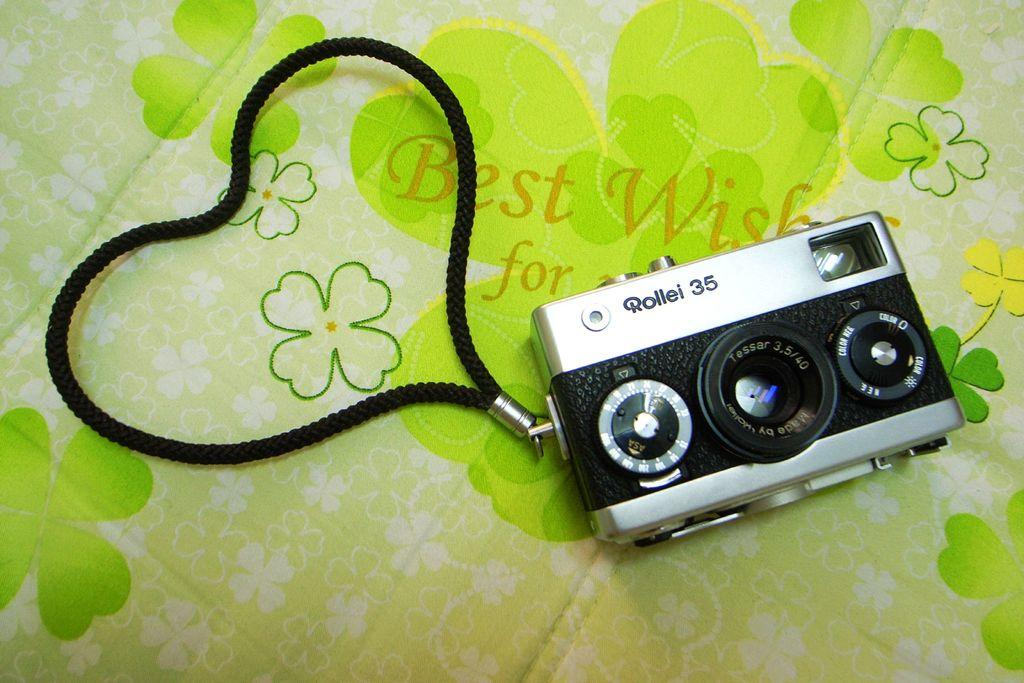<image>
Share a concise interpretation of the image provided. A black and silver Rollei 35 camera shown laying on green and white piece of material. 